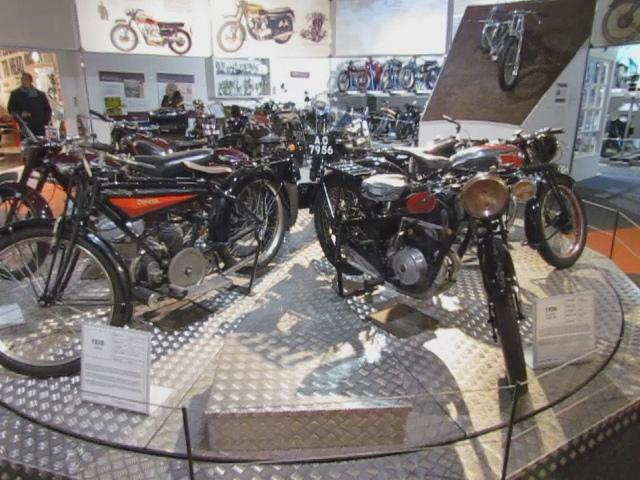What sort of shop is this?

Choices:
A) motorcycle sales
B) car sales
C) used car
D) motorcycle repair motorcycle sales 